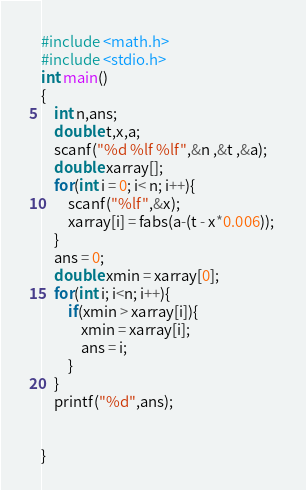Convert code to text. <code><loc_0><loc_0><loc_500><loc_500><_C_>#include <math.h>
#include <stdio.h>
int main()
{
	int n,ans;
	double t,x,a;
	scanf("%d %lf %lf",&n ,&t ,&a);
	double xarray[];
	for(int i = 0; i< n; i++){
		scanf("%lf",&x);
		xarray[i] = fabs(a-(t - x*0.006)); 
	}
	ans = 0;
	double xmin = xarray[0];
	for(int i; i<n; i++){
		if(xmin > xarray[i]){
			xmin = xarray[i];
			ans = i;
		}
	}
	printf("%d",ans);
	
	
}
</code> 